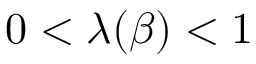<formula> <loc_0><loc_0><loc_500><loc_500>0 < \lambda ( \beta ) < 1</formula> 